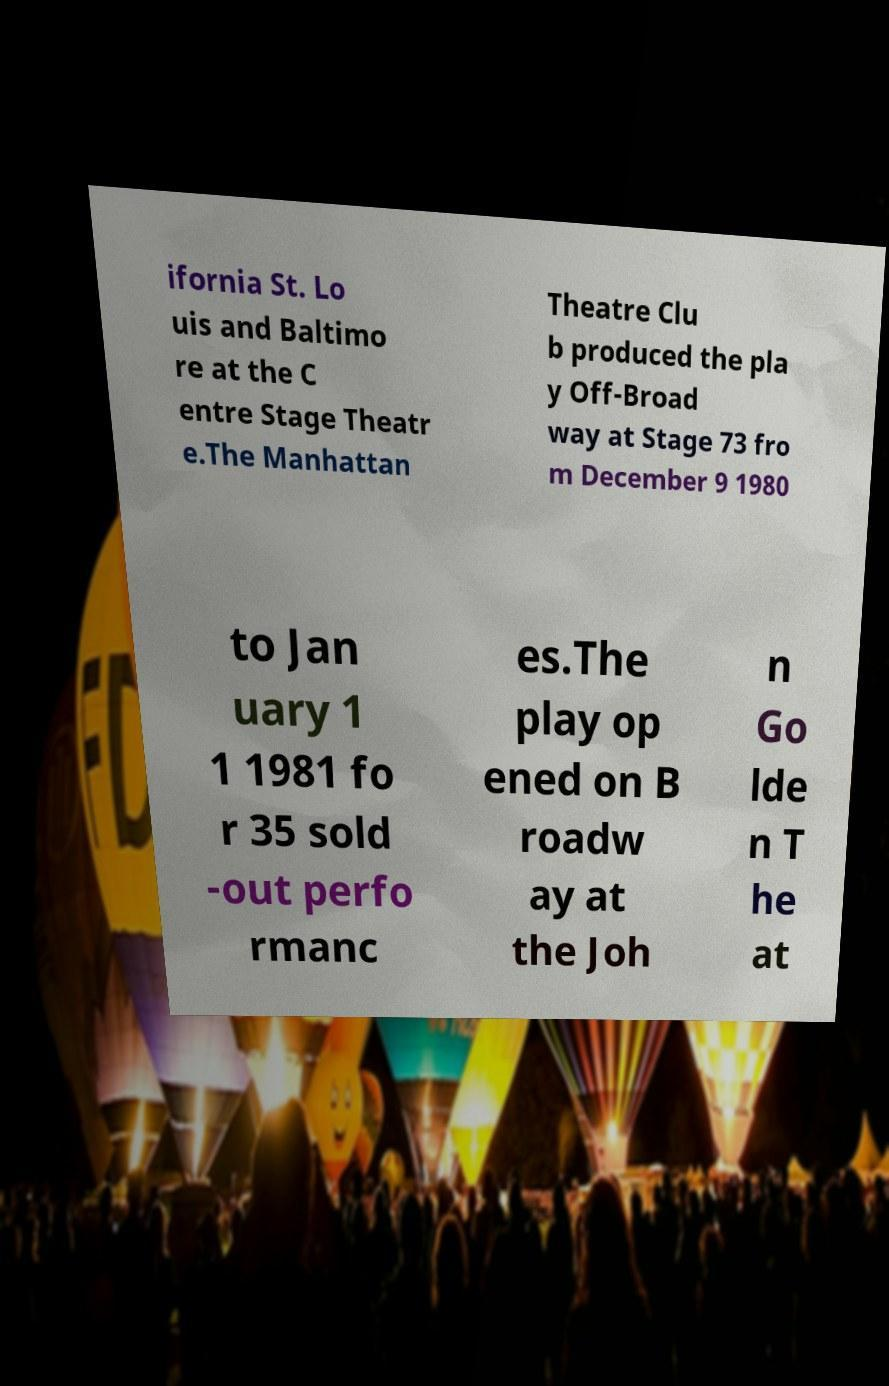I need the written content from this picture converted into text. Can you do that? ifornia St. Lo uis and Baltimo re at the C entre Stage Theatr e.The Manhattan Theatre Clu b produced the pla y Off-Broad way at Stage 73 fro m December 9 1980 to Jan uary 1 1 1981 fo r 35 sold -out perfo rmanc es.The play op ened on B roadw ay at the Joh n Go lde n T he at 